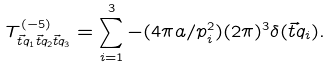Convert formula to latex. <formula><loc_0><loc_0><loc_500><loc_500>T ^ { ( - 5 ) } _ { \vec { t } q _ { 1 } \vec { t } q _ { 2 } \vec { t } q _ { 3 } } = \sum _ { i = 1 } ^ { 3 } - ( 4 \pi a / p _ { i } ^ { 2 } ) ( 2 \pi ) ^ { 3 } \delta ( \vec { t } q _ { i } ) .</formula> 